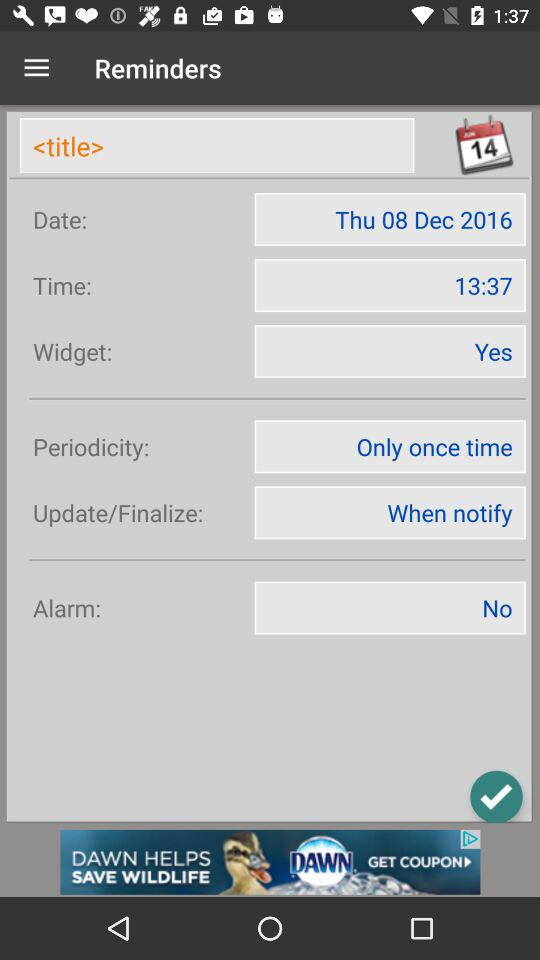Is the alarm set or not? No, the alarm is not set. 